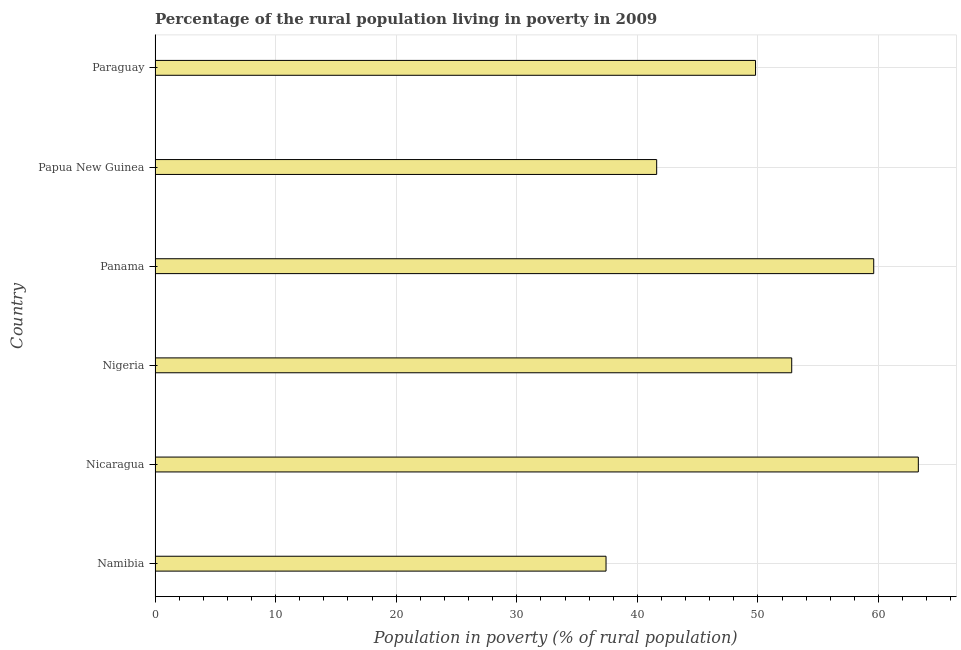Does the graph contain any zero values?
Make the answer very short. No. Does the graph contain grids?
Give a very brief answer. Yes. What is the title of the graph?
Ensure brevity in your answer.  Percentage of the rural population living in poverty in 2009. What is the label or title of the X-axis?
Offer a terse response. Population in poverty (% of rural population). What is the label or title of the Y-axis?
Give a very brief answer. Country. What is the percentage of rural population living below poverty line in Paraguay?
Your answer should be compact. 49.8. Across all countries, what is the maximum percentage of rural population living below poverty line?
Give a very brief answer. 63.3. Across all countries, what is the minimum percentage of rural population living below poverty line?
Ensure brevity in your answer.  37.4. In which country was the percentage of rural population living below poverty line maximum?
Keep it short and to the point. Nicaragua. In which country was the percentage of rural population living below poverty line minimum?
Provide a short and direct response. Namibia. What is the sum of the percentage of rural population living below poverty line?
Provide a short and direct response. 304.5. What is the average percentage of rural population living below poverty line per country?
Your answer should be very brief. 50.75. What is the median percentage of rural population living below poverty line?
Offer a very short reply. 51.3. What is the ratio of the percentage of rural population living below poverty line in Nicaragua to that in Paraguay?
Provide a succinct answer. 1.27. Is the difference between the percentage of rural population living below poverty line in Nigeria and Panama greater than the difference between any two countries?
Offer a terse response. No. What is the difference between the highest and the lowest percentage of rural population living below poverty line?
Give a very brief answer. 25.9. In how many countries, is the percentage of rural population living below poverty line greater than the average percentage of rural population living below poverty line taken over all countries?
Offer a very short reply. 3. Are all the bars in the graph horizontal?
Make the answer very short. Yes. What is the difference between two consecutive major ticks on the X-axis?
Provide a succinct answer. 10. What is the Population in poverty (% of rural population) in Namibia?
Provide a short and direct response. 37.4. What is the Population in poverty (% of rural population) of Nicaragua?
Your answer should be compact. 63.3. What is the Population in poverty (% of rural population) of Nigeria?
Ensure brevity in your answer.  52.8. What is the Population in poverty (% of rural population) in Panama?
Offer a terse response. 59.6. What is the Population in poverty (% of rural population) in Papua New Guinea?
Offer a terse response. 41.6. What is the Population in poverty (% of rural population) in Paraguay?
Your answer should be compact. 49.8. What is the difference between the Population in poverty (% of rural population) in Namibia and Nicaragua?
Give a very brief answer. -25.9. What is the difference between the Population in poverty (% of rural population) in Namibia and Nigeria?
Your answer should be compact. -15.4. What is the difference between the Population in poverty (% of rural population) in Namibia and Panama?
Provide a short and direct response. -22.2. What is the difference between the Population in poverty (% of rural population) in Nicaragua and Panama?
Offer a very short reply. 3.7. What is the difference between the Population in poverty (% of rural population) in Nicaragua and Papua New Guinea?
Your answer should be compact. 21.7. What is the difference between the Population in poverty (% of rural population) in Nicaragua and Paraguay?
Your answer should be very brief. 13.5. What is the difference between the Population in poverty (% of rural population) in Nigeria and Panama?
Your answer should be very brief. -6.8. What is the difference between the Population in poverty (% of rural population) in Nigeria and Paraguay?
Provide a succinct answer. 3. What is the difference between the Population in poverty (% of rural population) in Papua New Guinea and Paraguay?
Provide a short and direct response. -8.2. What is the ratio of the Population in poverty (% of rural population) in Namibia to that in Nicaragua?
Keep it short and to the point. 0.59. What is the ratio of the Population in poverty (% of rural population) in Namibia to that in Nigeria?
Keep it short and to the point. 0.71. What is the ratio of the Population in poverty (% of rural population) in Namibia to that in Panama?
Give a very brief answer. 0.63. What is the ratio of the Population in poverty (% of rural population) in Namibia to that in Papua New Guinea?
Ensure brevity in your answer.  0.9. What is the ratio of the Population in poverty (% of rural population) in Namibia to that in Paraguay?
Your answer should be very brief. 0.75. What is the ratio of the Population in poverty (% of rural population) in Nicaragua to that in Nigeria?
Offer a terse response. 1.2. What is the ratio of the Population in poverty (% of rural population) in Nicaragua to that in Panama?
Ensure brevity in your answer.  1.06. What is the ratio of the Population in poverty (% of rural population) in Nicaragua to that in Papua New Guinea?
Offer a very short reply. 1.52. What is the ratio of the Population in poverty (% of rural population) in Nicaragua to that in Paraguay?
Ensure brevity in your answer.  1.27. What is the ratio of the Population in poverty (% of rural population) in Nigeria to that in Panama?
Offer a terse response. 0.89. What is the ratio of the Population in poverty (% of rural population) in Nigeria to that in Papua New Guinea?
Your response must be concise. 1.27. What is the ratio of the Population in poverty (% of rural population) in Nigeria to that in Paraguay?
Keep it short and to the point. 1.06. What is the ratio of the Population in poverty (% of rural population) in Panama to that in Papua New Guinea?
Your answer should be very brief. 1.43. What is the ratio of the Population in poverty (% of rural population) in Panama to that in Paraguay?
Your answer should be very brief. 1.2. What is the ratio of the Population in poverty (% of rural population) in Papua New Guinea to that in Paraguay?
Keep it short and to the point. 0.83. 